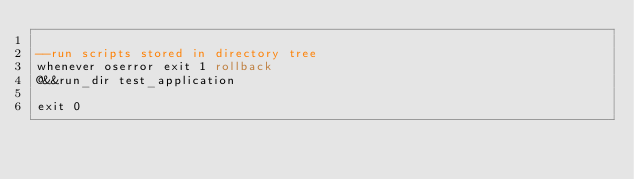<code> <loc_0><loc_0><loc_500><loc_500><_SQL_>
--run scripts stored in directory tree
whenever oserror exit 1 rollback
@&&run_dir test_application

exit 0
</code> 